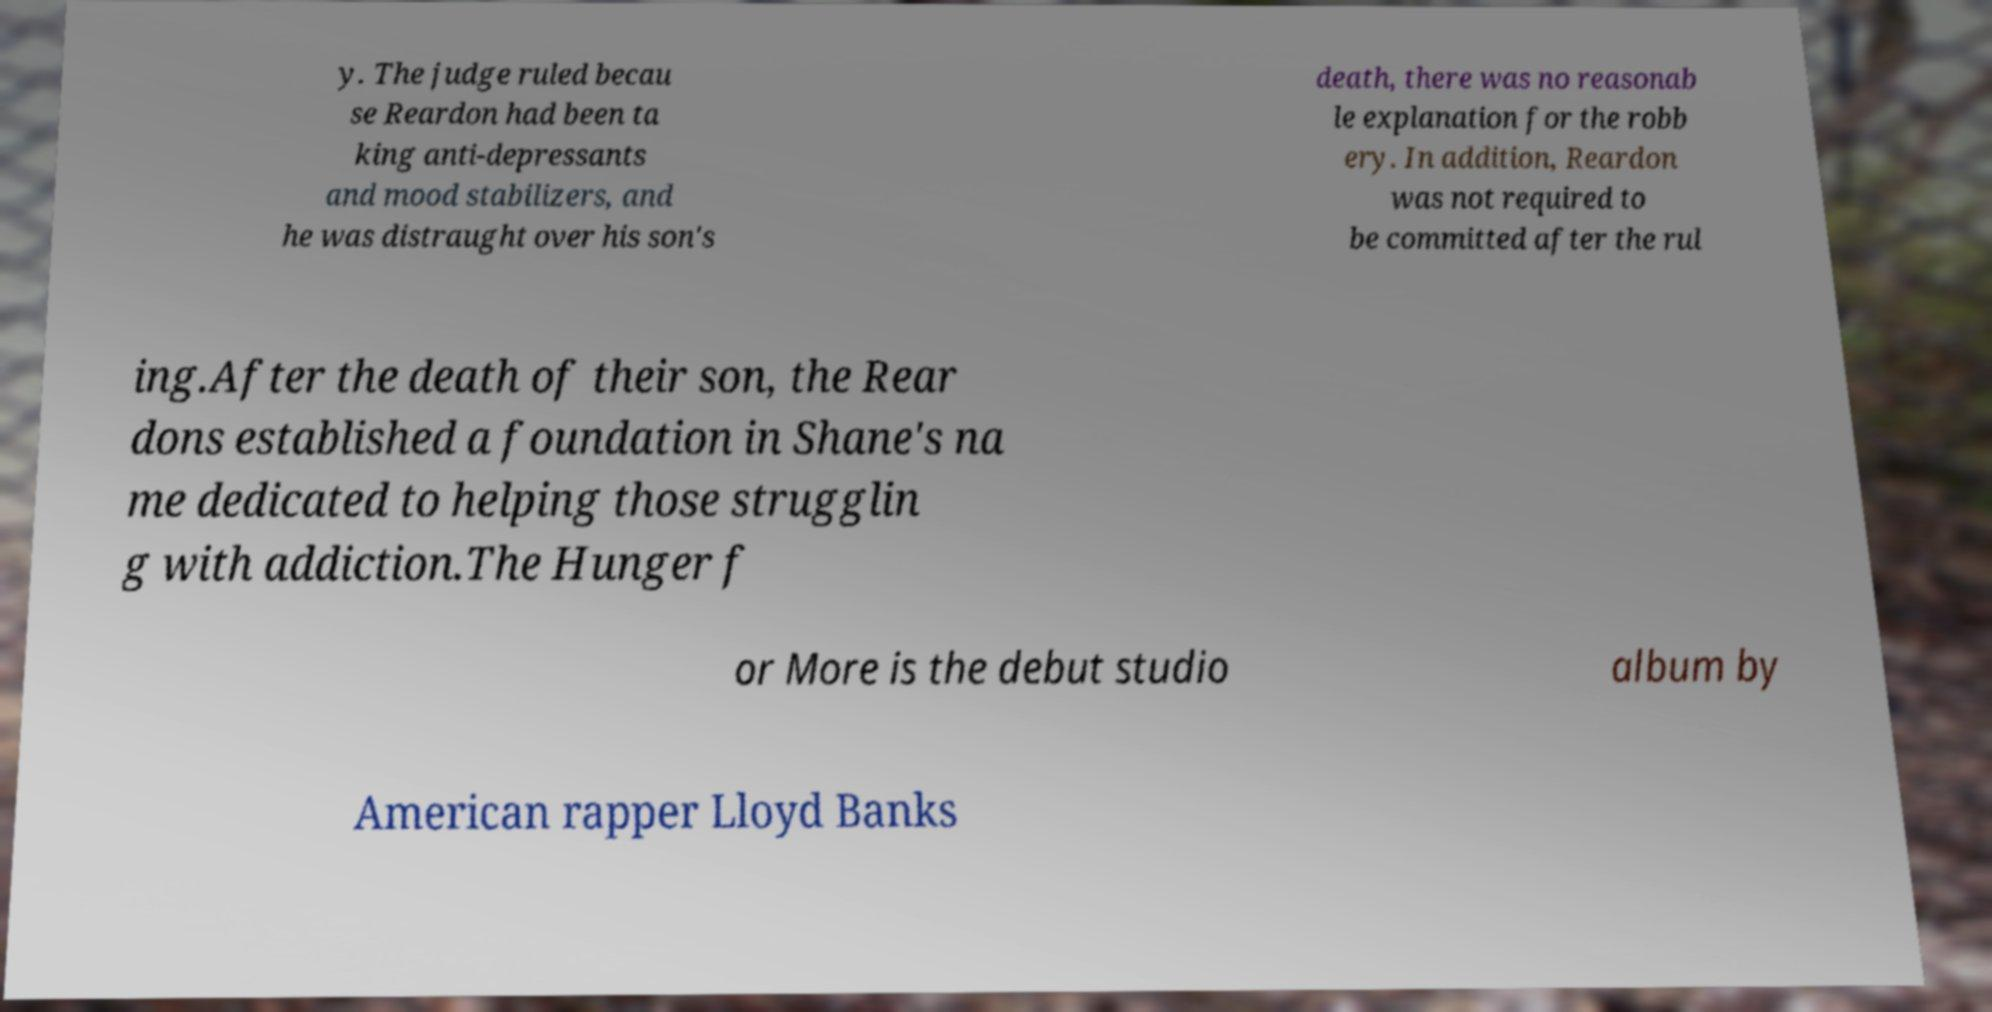What messages or text are displayed in this image? I need them in a readable, typed format. y. The judge ruled becau se Reardon had been ta king anti-depressants and mood stabilizers, and he was distraught over his son's death, there was no reasonab le explanation for the robb ery. In addition, Reardon was not required to be committed after the rul ing.After the death of their son, the Rear dons established a foundation in Shane's na me dedicated to helping those strugglin g with addiction.The Hunger f or More is the debut studio album by American rapper Lloyd Banks 